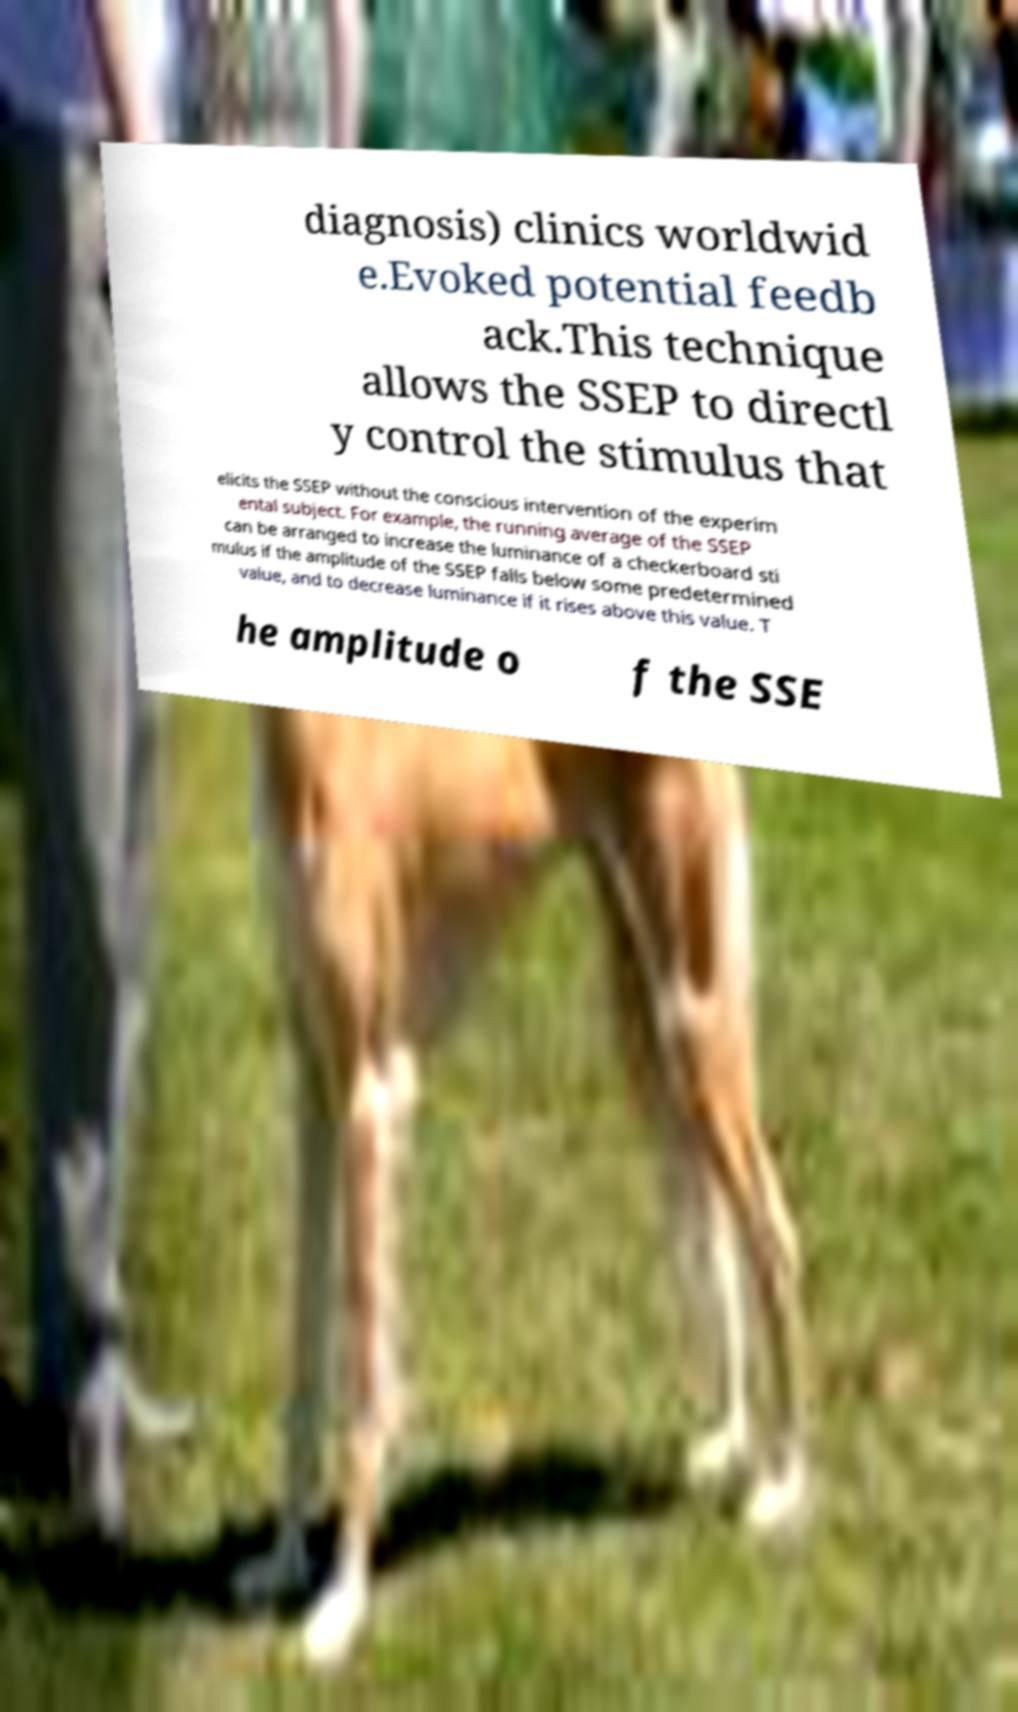Please read and relay the text visible in this image. What does it say? diagnosis) clinics worldwid e.Evoked potential feedb ack.This technique allows the SSEP to directl y control the stimulus that elicits the SSEP without the conscious intervention of the experim ental subject. For example, the running average of the SSEP can be arranged to increase the luminance of a checkerboard sti mulus if the amplitude of the SSEP falls below some predetermined value, and to decrease luminance if it rises above this value. T he amplitude o f the SSE 